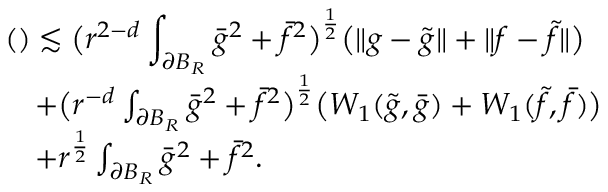<formula> <loc_0><loc_0><loc_500><loc_500>\begin{array} { r l } { { ( ) \lesssim \left ( r ^ { 2 - d } \int _ { \partial B _ { R } } \bar { g } ^ { 2 } + \bar { f } ^ { 2 } \right ) ^ { \frac { 1 } { 2 } } \left ( \| g - \tilde { g } \| + \| f - \tilde { f } \| \right ) } } \\ & { + \left ( r ^ { - d } \int _ { \partial B _ { R } } \bar { g } ^ { 2 } + \bar { f } ^ { 2 } \right ) ^ { \frac { 1 } { 2 } } \left ( W _ { 1 } ( \tilde { g } , \bar { g } ) + W _ { 1 } ( \tilde { f } , \bar { f } ) \right ) } \\ & { + r ^ { \frac { 1 } { 2 } } \int _ { \partial B _ { R } } \bar { g } ^ { 2 } + \bar { f } ^ { 2 } . } \end{array}</formula> 